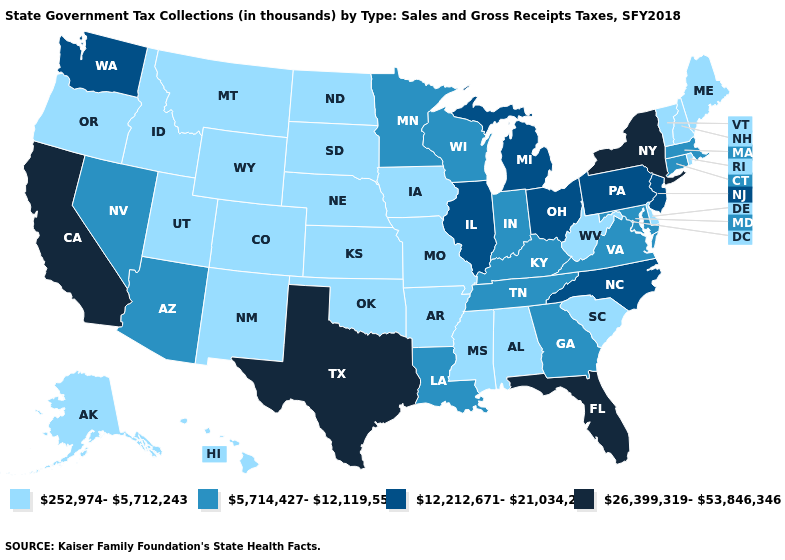What is the highest value in the Northeast ?
Be succinct. 26,399,319-53,846,346. Does Washington have a lower value than Florida?
Concise answer only. Yes. Does the map have missing data?
Concise answer only. No. What is the value of Iowa?
Be succinct. 252,974-5,712,243. Is the legend a continuous bar?
Quick response, please. No. Name the states that have a value in the range 12,212,671-21,034,252?
Write a very short answer. Illinois, Michigan, New Jersey, North Carolina, Ohio, Pennsylvania, Washington. Which states have the lowest value in the South?
Be succinct. Alabama, Arkansas, Delaware, Mississippi, Oklahoma, South Carolina, West Virginia. What is the highest value in states that border Florida?
Be succinct. 5,714,427-12,119,558. Which states have the lowest value in the Northeast?
Answer briefly. Maine, New Hampshire, Rhode Island, Vermont. Which states hav the highest value in the Northeast?
Quick response, please. New York. What is the value of California?
Quick response, please. 26,399,319-53,846,346. Name the states that have a value in the range 12,212,671-21,034,252?
Quick response, please. Illinois, Michigan, New Jersey, North Carolina, Ohio, Pennsylvania, Washington. Name the states that have a value in the range 26,399,319-53,846,346?
Concise answer only. California, Florida, New York, Texas. What is the value of Oregon?
Be succinct. 252,974-5,712,243. What is the value of Michigan?
Concise answer only. 12,212,671-21,034,252. 